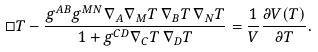<formula> <loc_0><loc_0><loc_500><loc_500>\Box T - \frac { g ^ { A B } g ^ { M N } \nabla _ { A } \nabla _ { M } T \, \nabla _ { B } T \, \nabla _ { N } T } { 1 + g ^ { C D } \nabla _ { C } T \, \nabla _ { D } T } = \frac { 1 } { V } \frac { \partial V ( T ) } { \partial T } .</formula> 